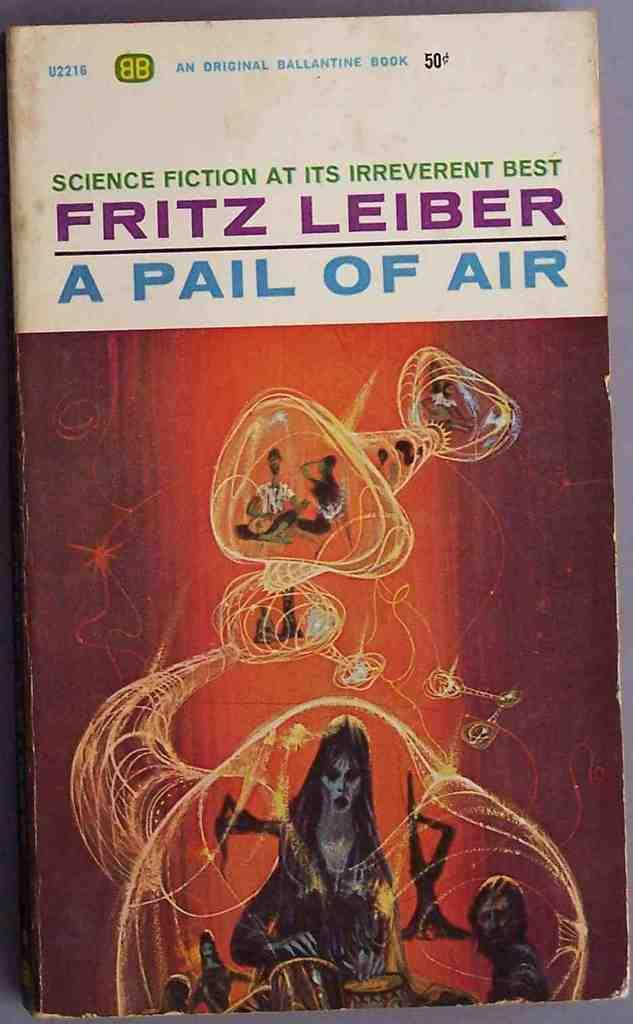<image>
Offer a succinct explanation of the picture presented. An original Ballantine book cover stating Science Fiction at it's irreverent best. 